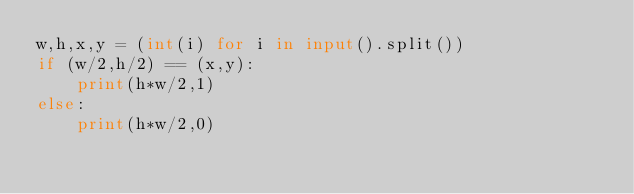<code> <loc_0><loc_0><loc_500><loc_500><_Python_>w,h,x,y = (int(i) for i in input().split())
if (w/2,h/2) == (x,y):
    print(h*w/2,1)
else:
    print(h*w/2,0)
</code> 